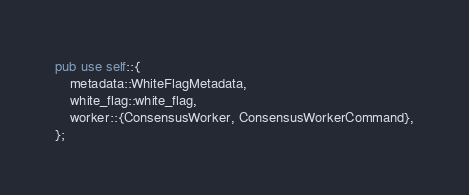Convert code to text. <code><loc_0><loc_0><loc_500><loc_500><_Rust_>pub use self::{
    metadata::WhiteFlagMetadata,
    white_flag::white_flag,
    worker::{ConsensusWorker, ConsensusWorkerCommand},
};
</code> 